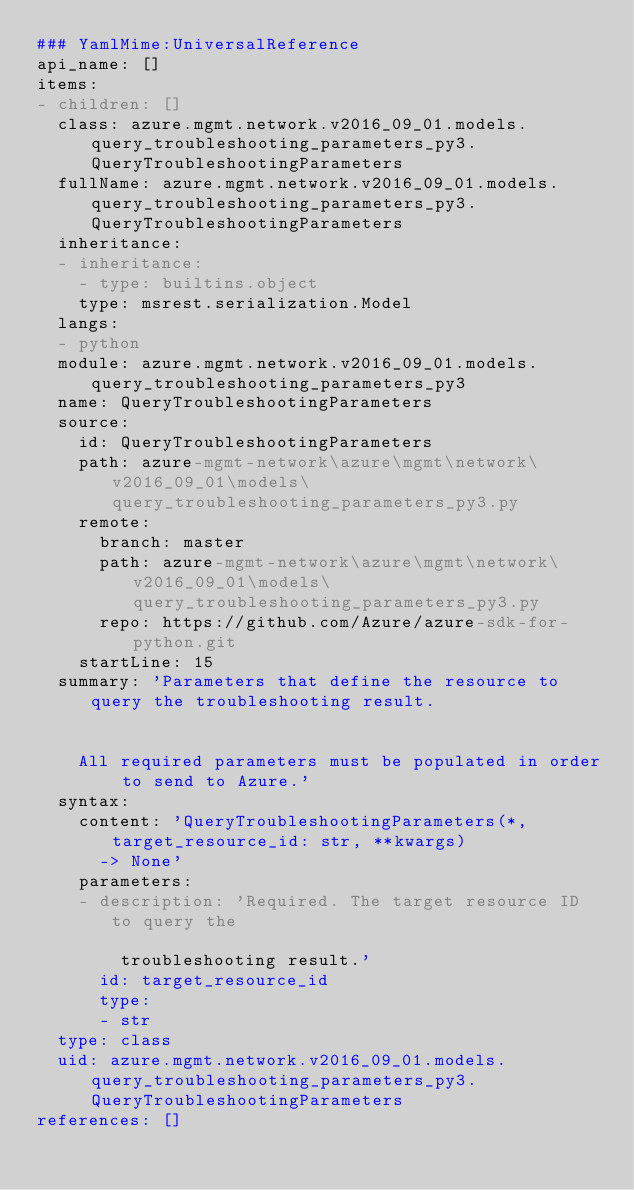<code> <loc_0><loc_0><loc_500><loc_500><_YAML_>### YamlMime:UniversalReference
api_name: []
items:
- children: []
  class: azure.mgmt.network.v2016_09_01.models.query_troubleshooting_parameters_py3.QueryTroubleshootingParameters
  fullName: azure.mgmt.network.v2016_09_01.models.query_troubleshooting_parameters_py3.QueryTroubleshootingParameters
  inheritance:
  - inheritance:
    - type: builtins.object
    type: msrest.serialization.Model
  langs:
  - python
  module: azure.mgmt.network.v2016_09_01.models.query_troubleshooting_parameters_py3
  name: QueryTroubleshootingParameters
  source:
    id: QueryTroubleshootingParameters
    path: azure-mgmt-network\azure\mgmt\network\v2016_09_01\models\query_troubleshooting_parameters_py3.py
    remote:
      branch: master
      path: azure-mgmt-network\azure\mgmt\network\v2016_09_01\models\query_troubleshooting_parameters_py3.py
      repo: https://github.com/Azure/azure-sdk-for-python.git
    startLine: 15
  summary: 'Parameters that define the resource to query the troubleshooting result.


    All required parameters must be populated in order to send to Azure.'
  syntax:
    content: 'QueryTroubleshootingParameters(*, target_resource_id: str, **kwargs)
      -> None'
    parameters:
    - description: 'Required. The target resource ID to query the

        troubleshooting result.'
      id: target_resource_id
      type:
      - str
  type: class
  uid: azure.mgmt.network.v2016_09_01.models.query_troubleshooting_parameters_py3.QueryTroubleshootingParameters
references: []
</code> 